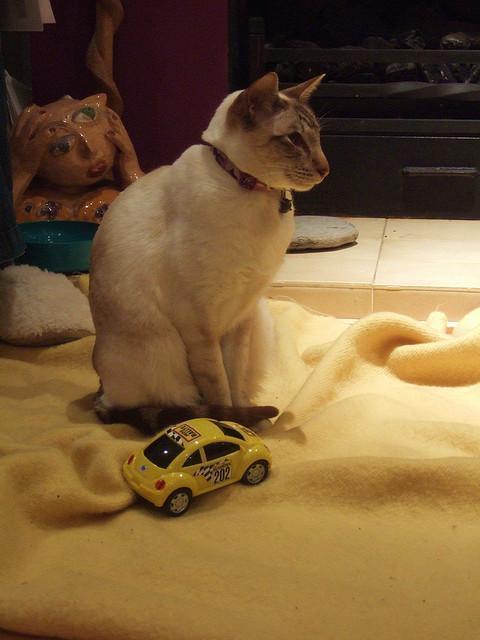How many beds can you see?
Give a very brief answer. 1. 